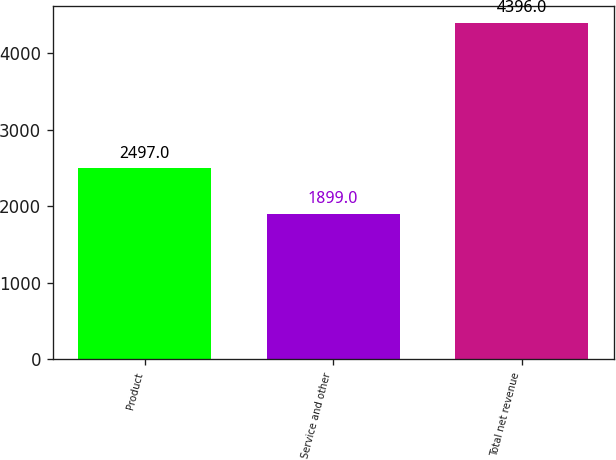Convert chart to OTSL. <chart><loc_0><loc_0><loc_500><loc_500><bar_chart><fcel>Product<fcel>Service and other<fcel>Total net revenue<nl><fcel>2497<fcel>1899<fcel>4396<nl></chart> 